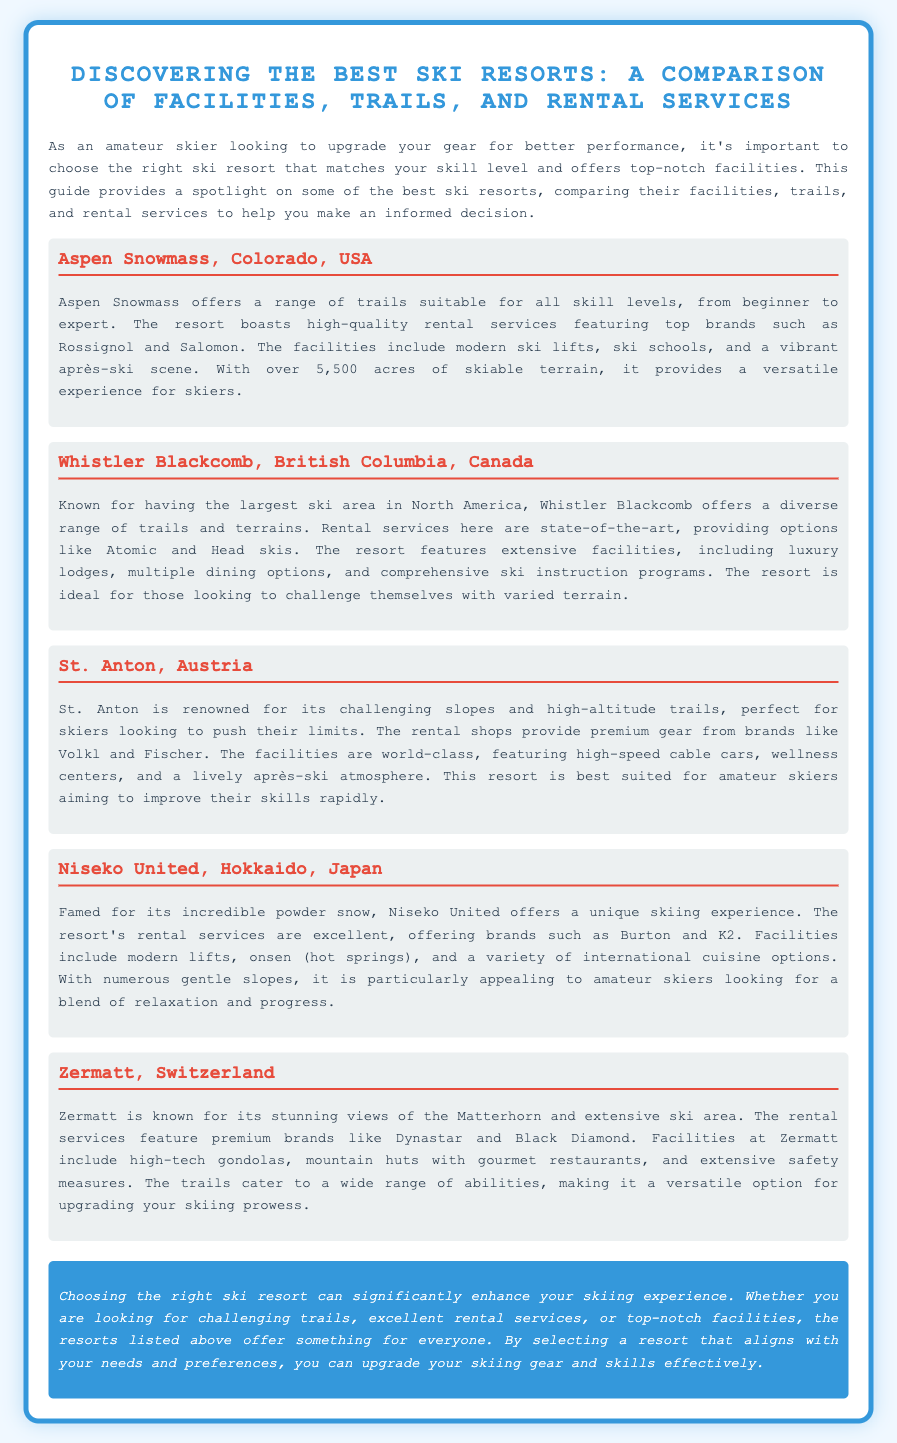What is the location of Aspen Snowmass? The location of Aspen Snowmass is in Colorado, USA.
Answer: Colorado, USA Which resort is known for its challenging slopes? St. Anton is renowned for its challenging slopes.
Answer: St. Anton What is the ski area size of Whistler Blackcomb? Whistler Blackcomb is known for having the largest ski area in North America.
Answer: Largest in North America What rental brands are available at Niseko United? Niseko United's rental services offer brands such as Burton and K2.
Answer: Burton and K2 What type of skiing experience does Aspen Snowmass provide? Aspen Snowmass provides a versatile experience for skiers.
Answer: Versatile experience Which resort features onsen facilities? Niseko United includes onsen (hot springs) in its facilities.
Answer: Niseko United What is notable about Zermatt's views? Zermatt is known for its stunning views of the Matterhorn.
Answer: Matterhorn What kind of atmosphere does St. Anton offer? St. Anton features a lively après-ski atmosphere.
Answer: Lively après-ski atmosphere 